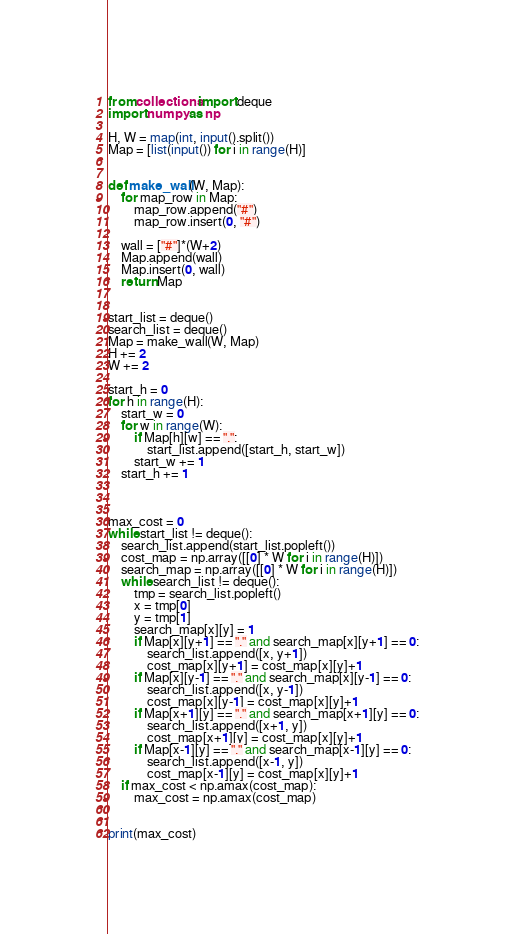Convert code to text. <code><loc_0><loc_0><loc_500><loc_500><_Python_>from collections import deque
import numpy as np

H, W = map(int, input().split())
Map = [list(input()) for i in range(H)]


def make_wall(W, Map):
    for map_row in Map:
        map_row.append("#")
        map_row.insert(0, "#")

    wall = ["#"]*(W+2)
    Map.append(wall)
    Map.insert(0, wall)
    return Map


start_list = deque()
search_list = deque()
Map = make_wall(W, Map)
H += 2
W += 2

start_h = 0
for h in range(H):
    start_w = 0
    for w in range(W):
        if Map[h][w] == ".":
            start_list.append([start_h, start_w])
        start_w += 1
    start_h += 1



max_cost = 0
while start_list != deque():
    search_list.append(start_list.popleft())
    cost_map = np.array([[0] * W for i in range(H)])
    search_map = np.array([[0] * W for i in range(H)])
    while search_list != deque():
        tmp = search_list.popleft()
        x = tmp[0]
        y = tmp[1]
        search_map[x][y] = 1
        if Map[x][y+1] == "." and search_map[x][y+1] == 0:
            search_list.append([x, y+1])
            cost_map[x][y+1] = cost_map[x][y]+1
        if Map[x][y-1] == "." and search_map[x][y-1] == 0:
            search_list.append([x, y-1])
            cost_map[x][y-1] = cost_map[x][y]+1
        if Map[x+1][y] == "." and search_map[x+1][y] == 0:
            search_list.append([x+1, y])
            cost_map[x+1][y] = cost_map[x][y]+1
        if Map[x-1][y] == "." and search_map[x-1][y] == 0:
            search_list.append([x-1, y])
            cost_map[x-1][y] = cost_map[x][y]+1
    if max_cost < np.amax(cost_map):
        max_cost = np.amax(cost_map)


print(max_cost)</code> 